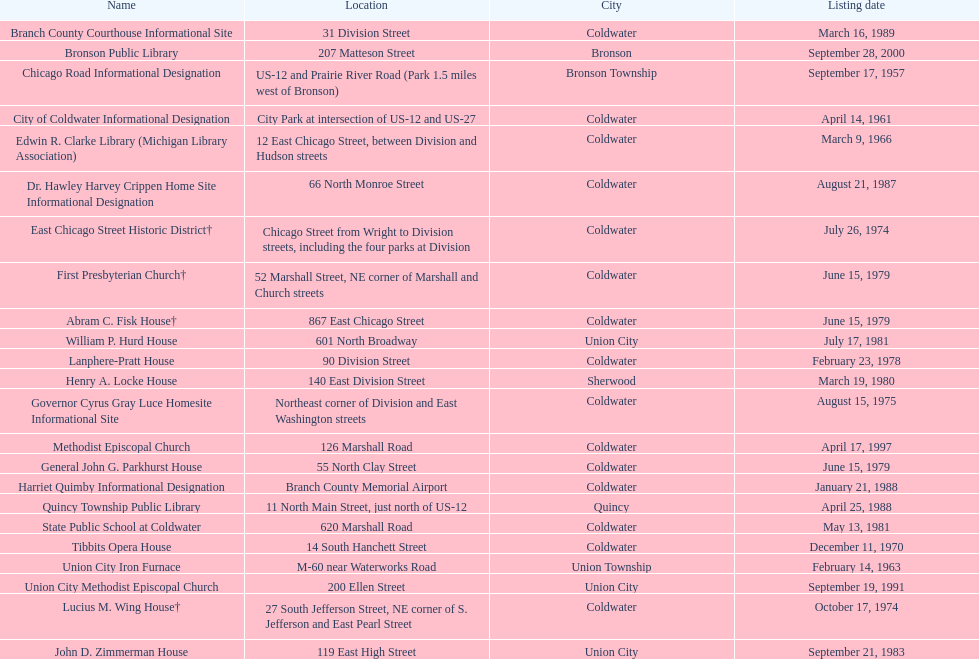Identify a location that was recorded not later than 196 Chicago Road Informational Designation. 